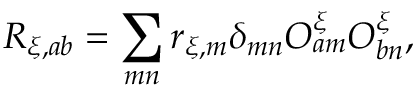Convert formula to latex. <formula><loc_0><loc_0><loc_500><loc_500>R _ { \xi , a b } = \sum _ { m n } r _ { \xi , m } \delta _ { m n } O _ { a m } ^ { \xi } O _ { b n } ^ { \xi } ,</formula> 